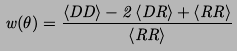<formula> <loc_0><loc_0><loc_500><loc_500>w ( \theta ) = \frac { \left < D D \right > - 2 \left < D R \right > + \left < R R \right > } { \left < R R \right > }</formula> 